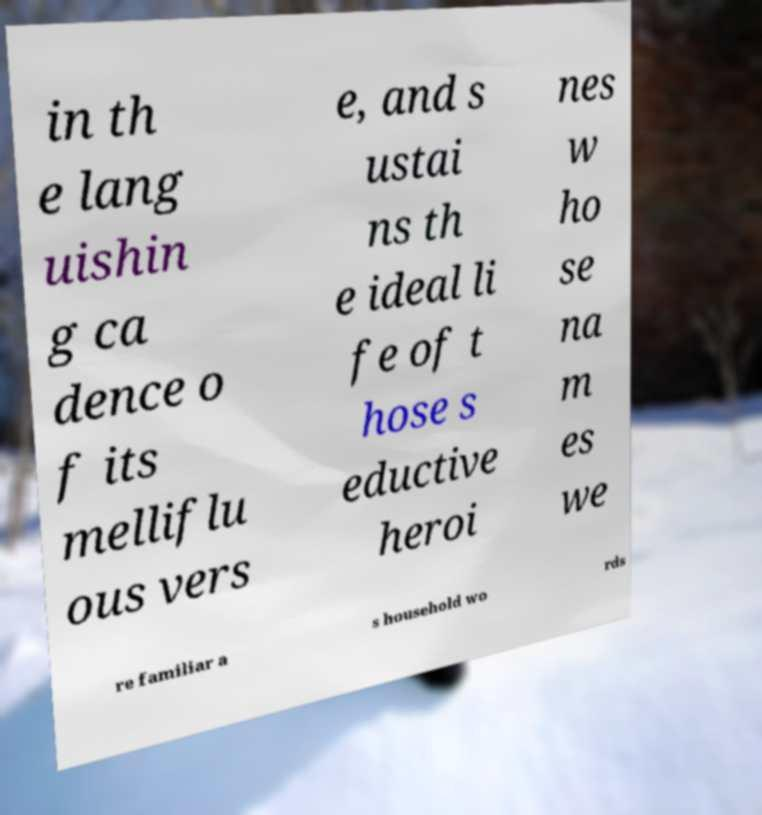Can you accurately transcribe the text from the provided image for me? in th e lang uishin g ca dence o f its melliflu ous vers e, and s ustai ns th e ideal li fe of t hose s eductive heroi nes w ho se na m es we re familiar a s household wo rds 